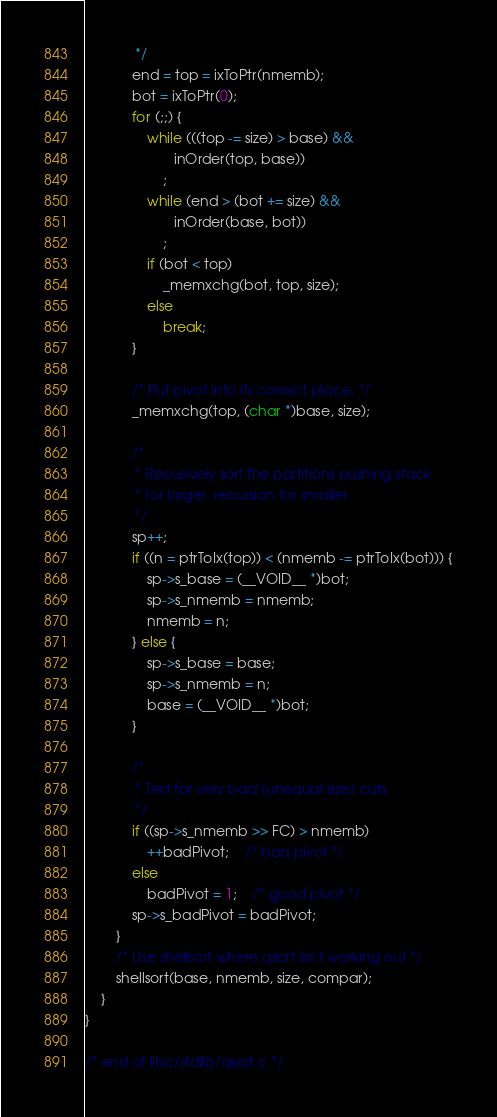<code> <loc_0><loc_0><loc_500><loc_500><_C_>			 */
			end = top = ixToPtr(nmemb);
			bot = ixToPtr(0);
			for (;;) {
				while (((top -= size) > base) &&
				       inOrder(top, base))
					;
				while (end > (bot += size) &&
				       inOrder(base, bot))
					;
				if (bot < top)
					_memxchg(bot, top, size);
				else
					break;
			}

			/* Put pivot into its correct place. */
			_memxchg(top, (char *)base, size);

			/*
			 * Recusively sort the partitions pushing stack
			 * for larger, recursion for smaller.
			 */
			sp++;
			if ((n = ptrToIx(top)) < (nmemb -= ptrToIx(bot))) {
				sp->s_base = (__VOID__ *)bot;
				sp->s_nmemb = nmemb;
				nmemb = n;
			} else {
				sp->s_base = base;
				sp->s_nmemb = n;
				base = (__VOID__ *)bot;
			}

			/*
			 * Test for very bad (unequal size) cuts
			 */
			if ((sp->s_nmemb >> FC) > nmemb)
				++badPivot;	/* bad pivot */
			else
				badPivot = 1;	/* good pivot */
			sp->s_badPivot = badPivot;
		}
		/* Use shellsort where qsort isn't working out */
		shellsort(base, nmemb, size, compar);
	}
}

/* end of libc/stdlib/qsort.c */
</code> 